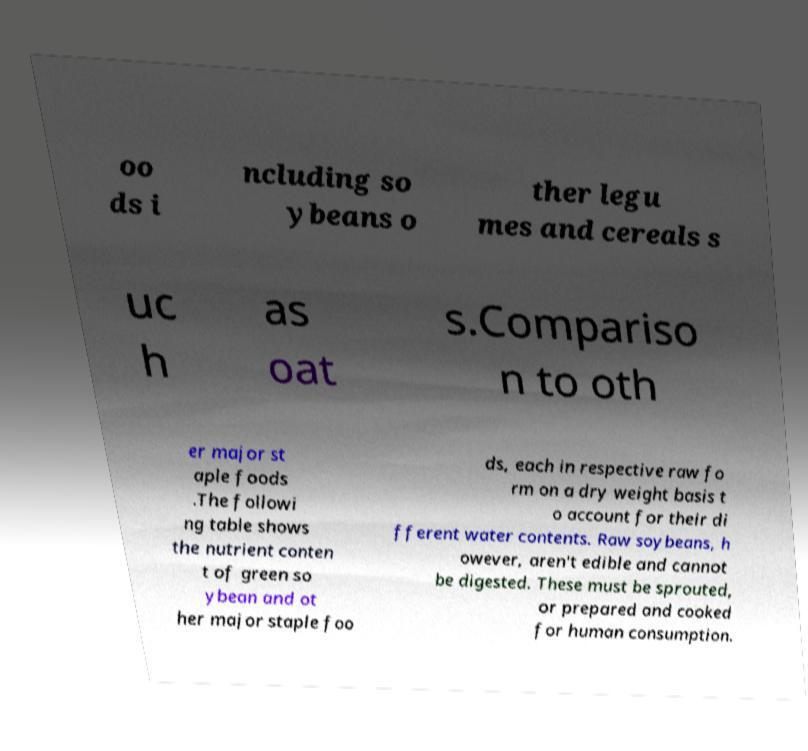Could you extract and type out the text from this image? oo ds i ncluding so ybeans o ther legu mes and cereals s uc h as oat s.Compariso n to oth er major st aple foods .The followi ng table shows the nutrient conten t of green so ybean and ot her major staple foo ds, each in respective raw fo rm on a dry weight basis t o account for their di fferent water contents. Raw soybeans, h owever, aren't edible and cannot be digested. These must be sprouted, or prepared and cooked for human consumption. 